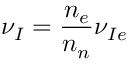Convert formula to latex. <formula><loc_0><loc_0><loc_500><loc_500>{ \nu _ { I } } = \frac { n _ { e } } { n _ { n } } \nu _ { I e }</formula> 